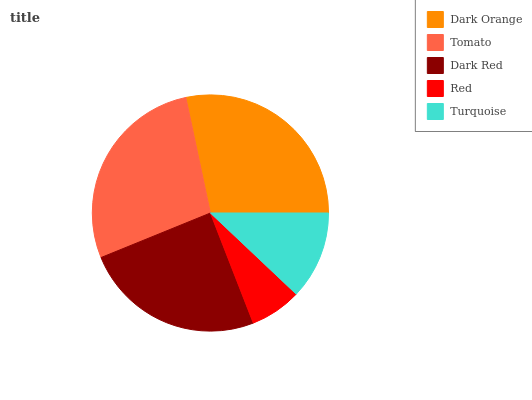Is Red the minimum?
Answer yes or no. Yes. Is Dark Orange the maximum?
Answer yes or no. Yes. Is Tomato the minimum?
Answer yes or no. No. Is Tomato the maximum?
Answer yes or no. No. Is Dark Orange greater than Tomato?
Answer yes or no. Yes. Is Tomato less than Dark Orange?
Answer yes or no. Yes. Is Tomato greater than Dark Orange?
Answer yes or no. No. Is Dark Orange less than Tomato?
Answer yes or no. No. Is Dark Red the high median?
Answer yes or no. Yes. Is Dark Red the low median?
Answer yes or no. Yes. Is Tomato the high median?
Answer yes or no. No. Is Turquoise the low median?
Answer yes or no. No. 